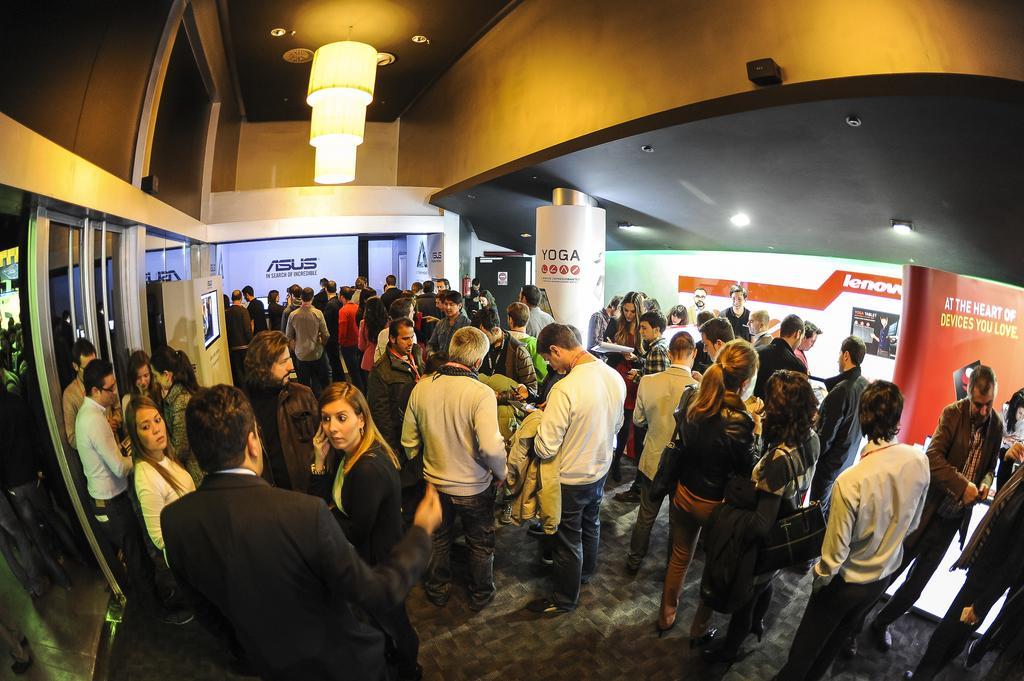Please provide a concise description of this image. This image is taken indoors. At the bottom of the image there is a floor. At the top of the image of there is a roof and there is a chandelier. In the middle of the image many people are standing on the floor and a few are holding objects in their hands. In the background there is a board with a text on it. There is a wall. There is a pillar. On the left side of the image there are a few glass doors and there is a wall. There is a board. On the right side of the image there are two boards with text on them and there is a banner with a text on it. 